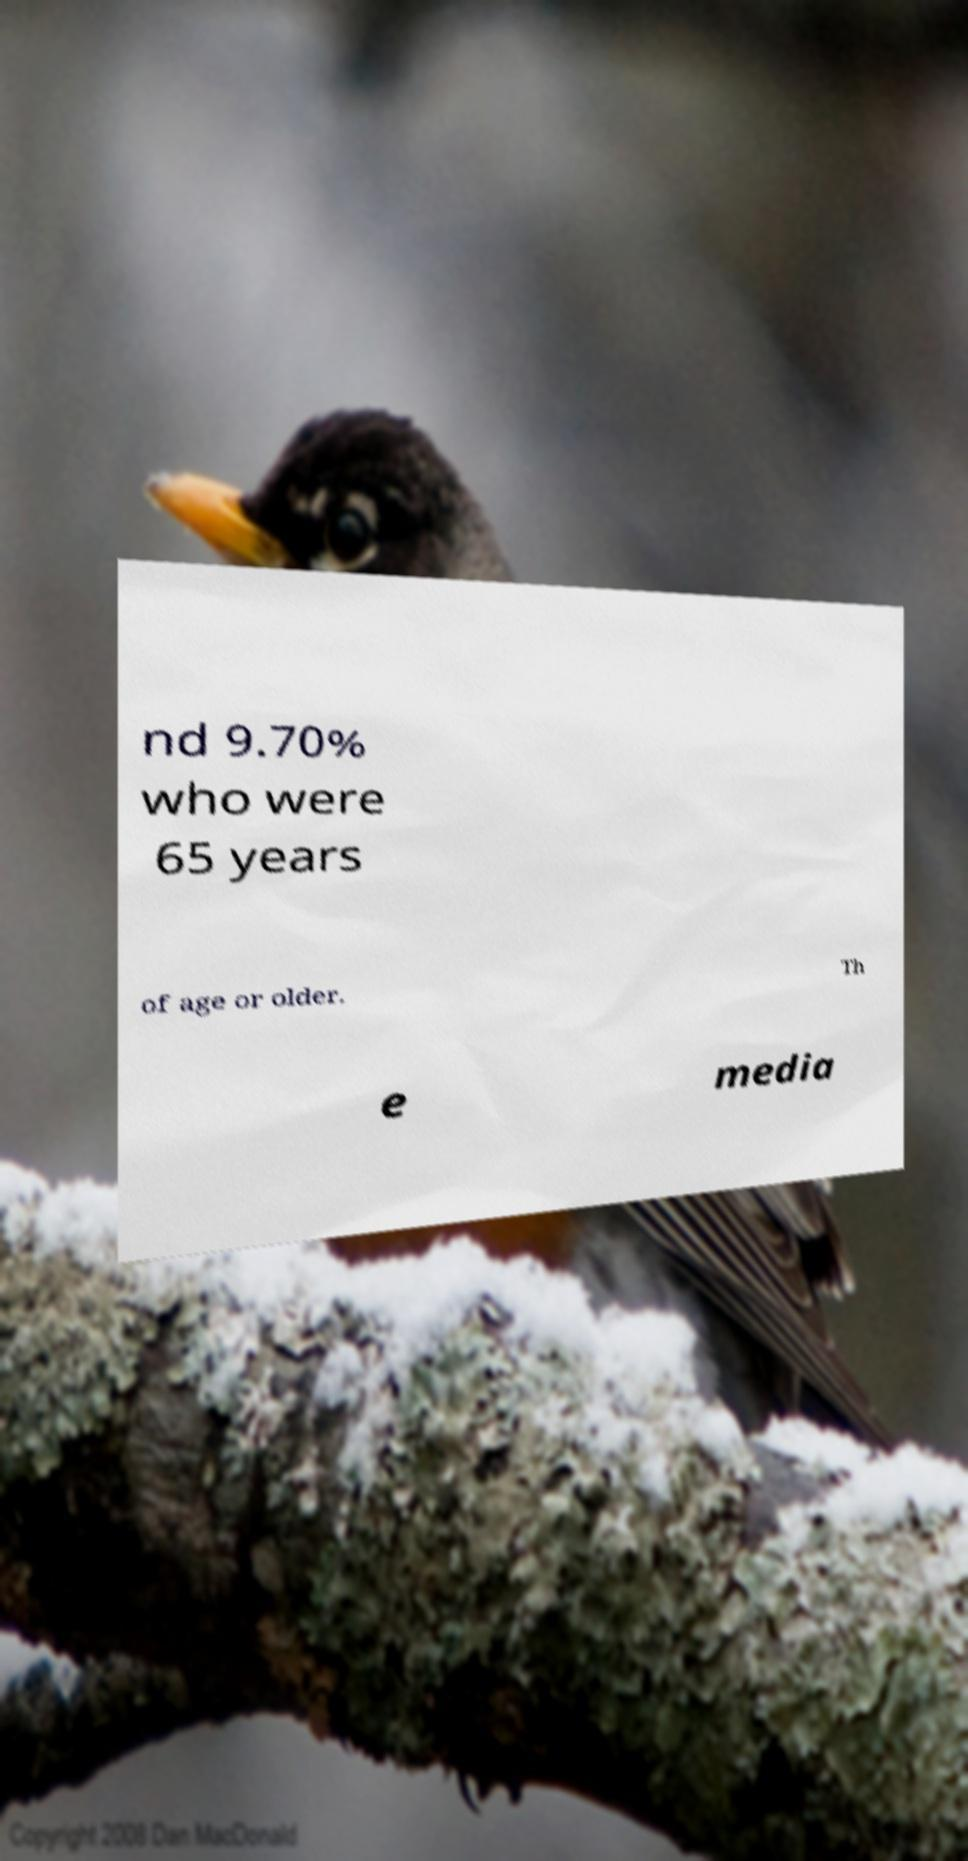There's text embedded in this image that I need extracted. Can you transcribe it verbatim? nd 9.70% who were 65 years of age or older. Th e media 